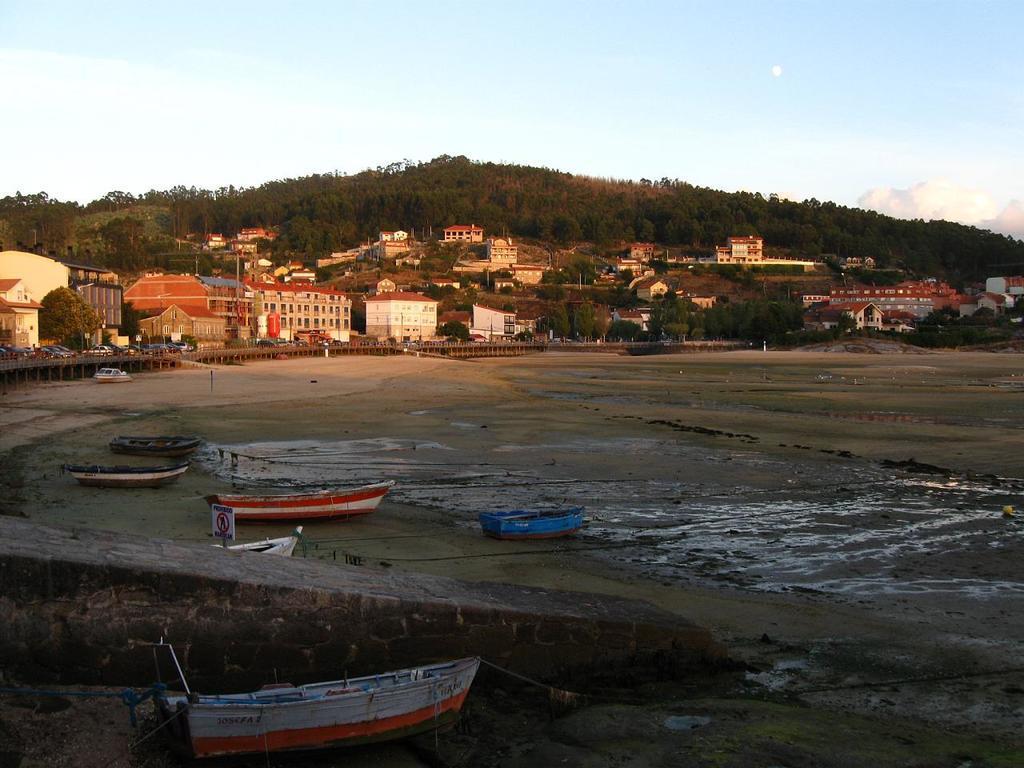Can you describe this image briefly? In this image we can see the mountains, some buildings, some vehicles on the road, one bridge, one wall, some boats on the ground, some poles, some objects on the ground, some wet ground, some trees, bushes and grass on the ground. At the top there is the sky. 